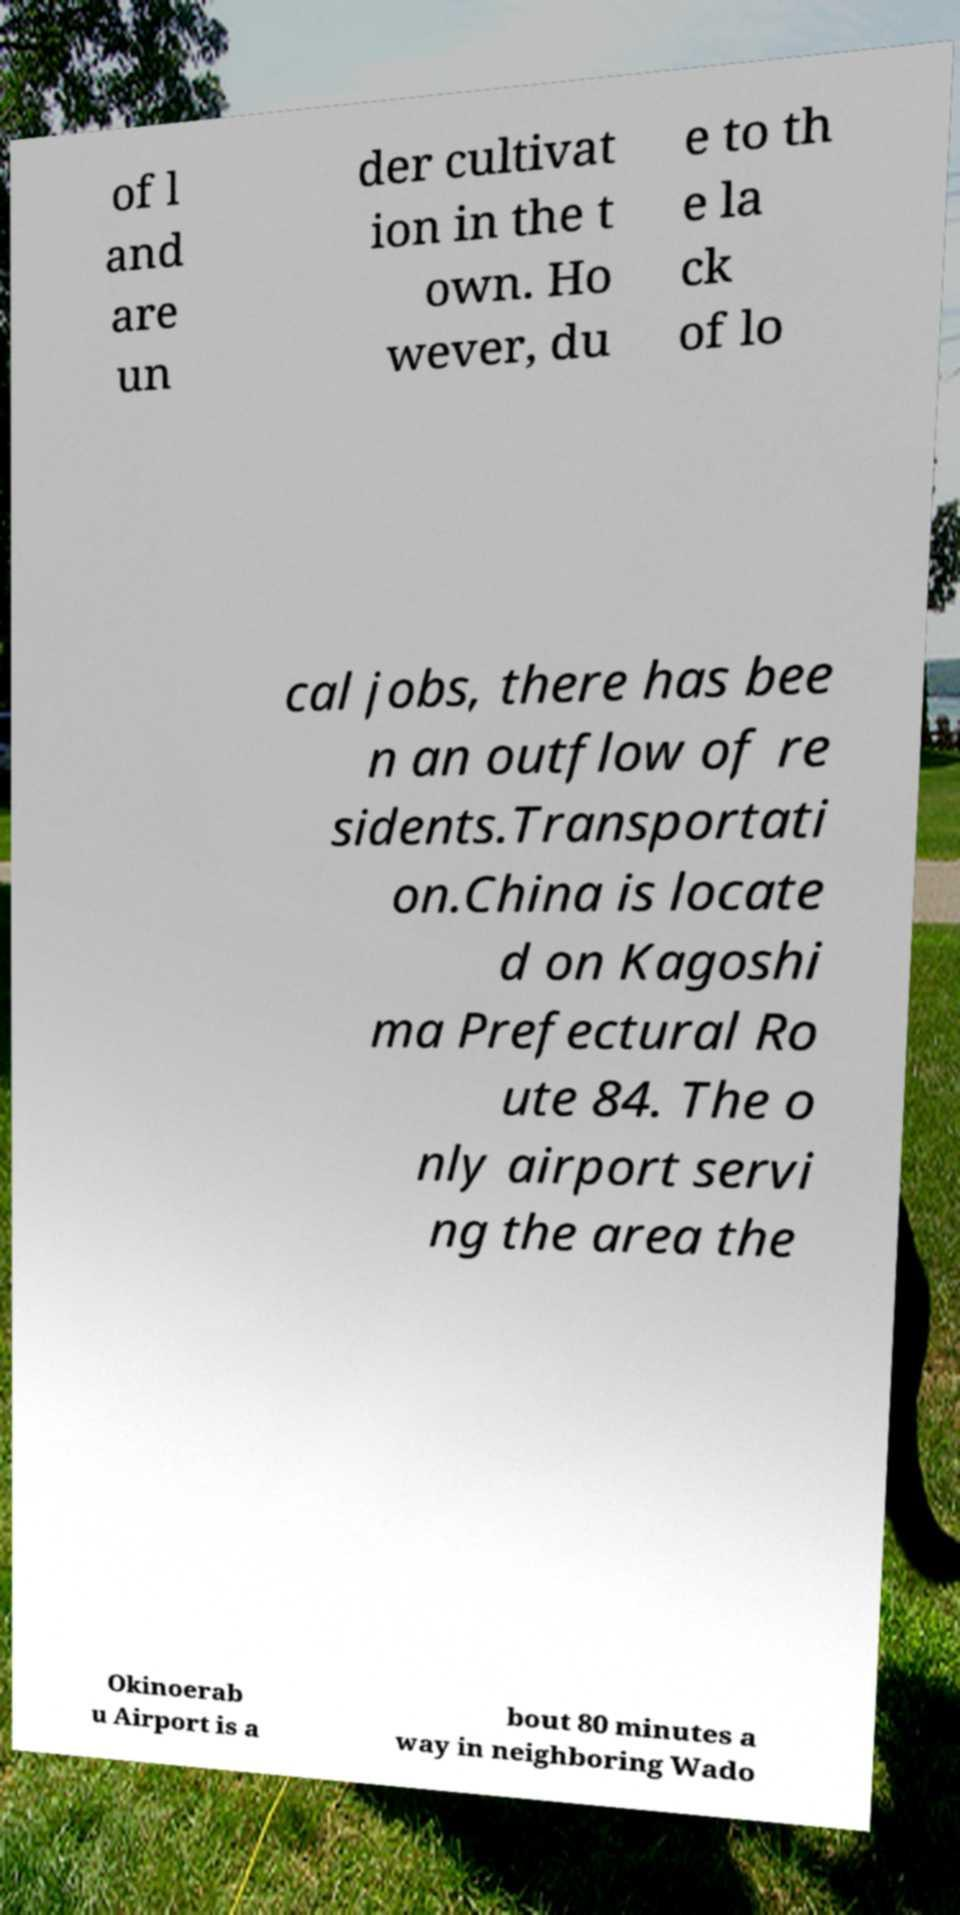I need the written content from this picture converted into text. Can you do that? of l and are un der cultivat ion in the t own. Ho wever, du e to th e la ck of lo cal jobs, there has bee n an outflow of re sidents.Transportati on.China is locate d on Kagoshi ma Prefectural Ro ute 84. The o nly airport servi ng the area the Okinoerab u Airport is a bout 80 minutes a way in neighboring Wado 